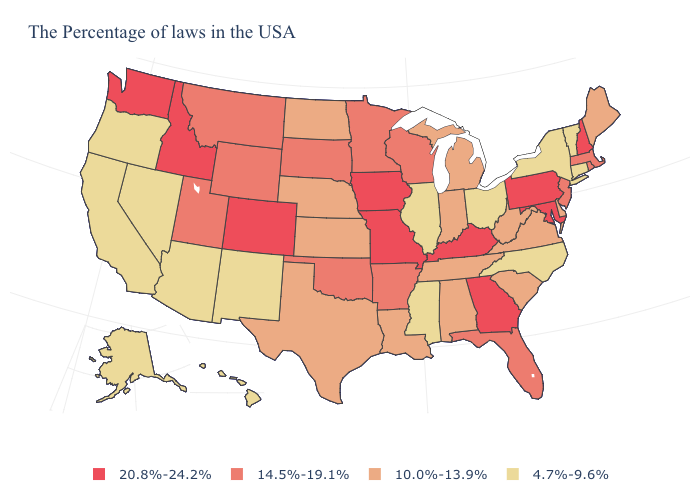Does the first symbol in the legend represent the smallest category?
Quick response, please. No. What is the value of Washington?
Answer briefly. 20.8%-24.2%. Does the map have missing data?
Give a very brief answer. No. Does Montana have the highest value in the West?
Give a very brief answer. No. What is the lowest value in the USA?
Give a very brief answer. 4.7%-9.6%. Among the states that border Michigan , which have the highest value?
Answer briefly. Wisconsin. Among the states that border Virginia , does Maryland have the highest value?
Quick response, please. Yes. How many symbols are there in the legend?
Give a very brief answer. 4. What is the lowest value in states that border Arkansas?
Give a very brief answer. 4.7%-9.6%. Does New York have the same value as Alabama?
Quick response, please. No. What is the lowest value in the Northeast?
Quick response, please. 4.7%-9.6%. What is the lowest value in the Northeast?
Give a very brief answer. 4.7%-9.6%. What is the value of Tennessee?
Concise answer only. 10.0%-13.9%. Name the states that have a value in the range 14.5%-19.1%?
Short answer required. Massachusetts, Rhode Island, New Jersey, Florida, Wisconsin, Arkansas, Minnesota, Oklahoma, South Dakota, Wyoming, Utah, Montana. Does Alaska have the lowest value in the USA?
Short answer required. Yes. 